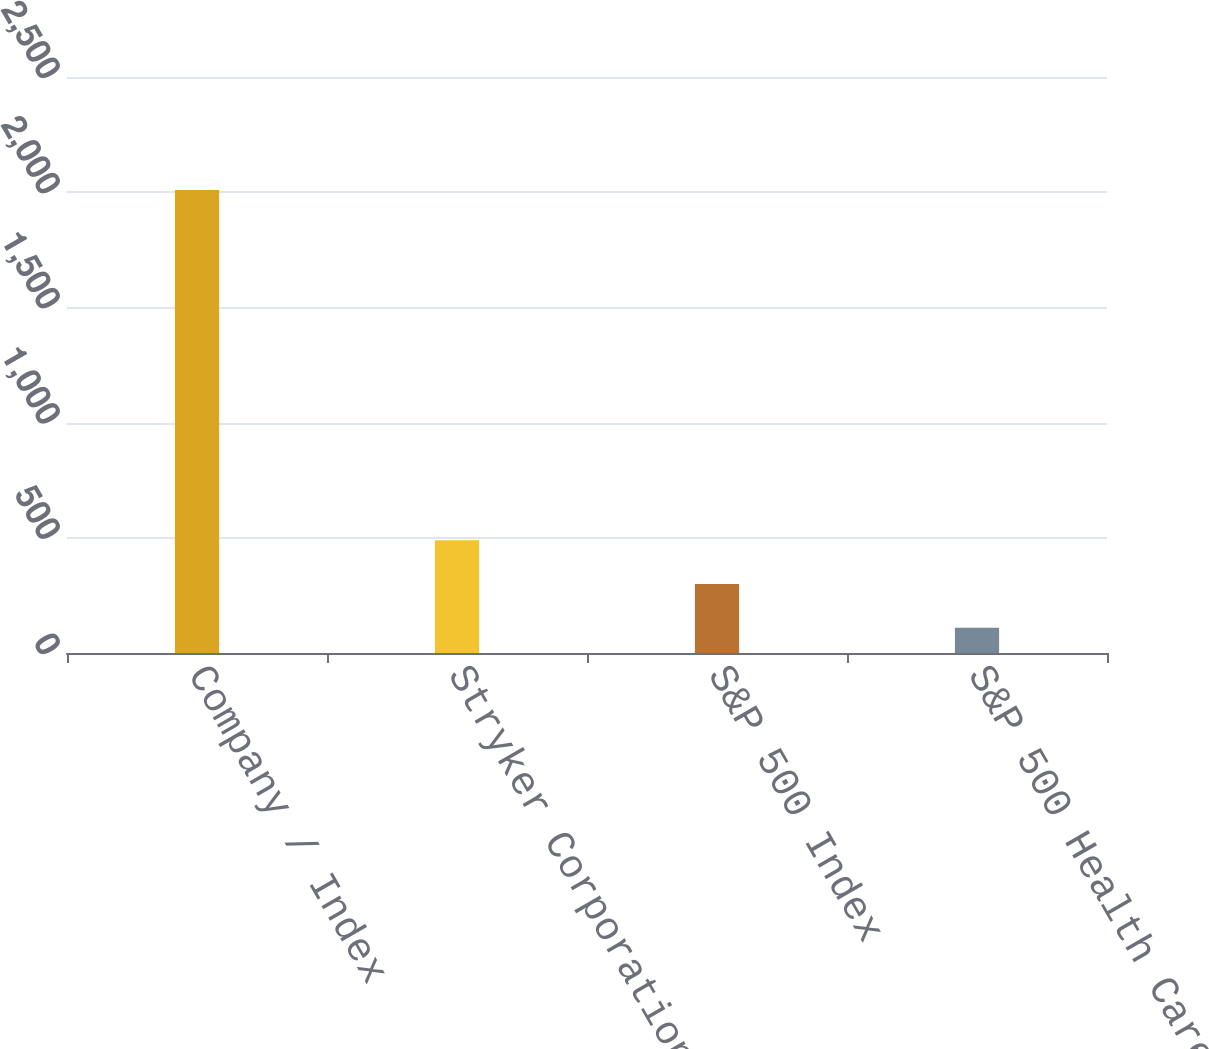Convert chart to OTSL. <chart><loc_0><loc_0><loc_500><loc_500><bar_chart><fcel>Company / Index<fcel>Stryker Corporation<fcel>S&P 500 Index<fcel>S&P 500 Health Care Index<nl><fcel>2010<fcel>489.65<fcel>299.6<fcel>109.55<nl></chart> 